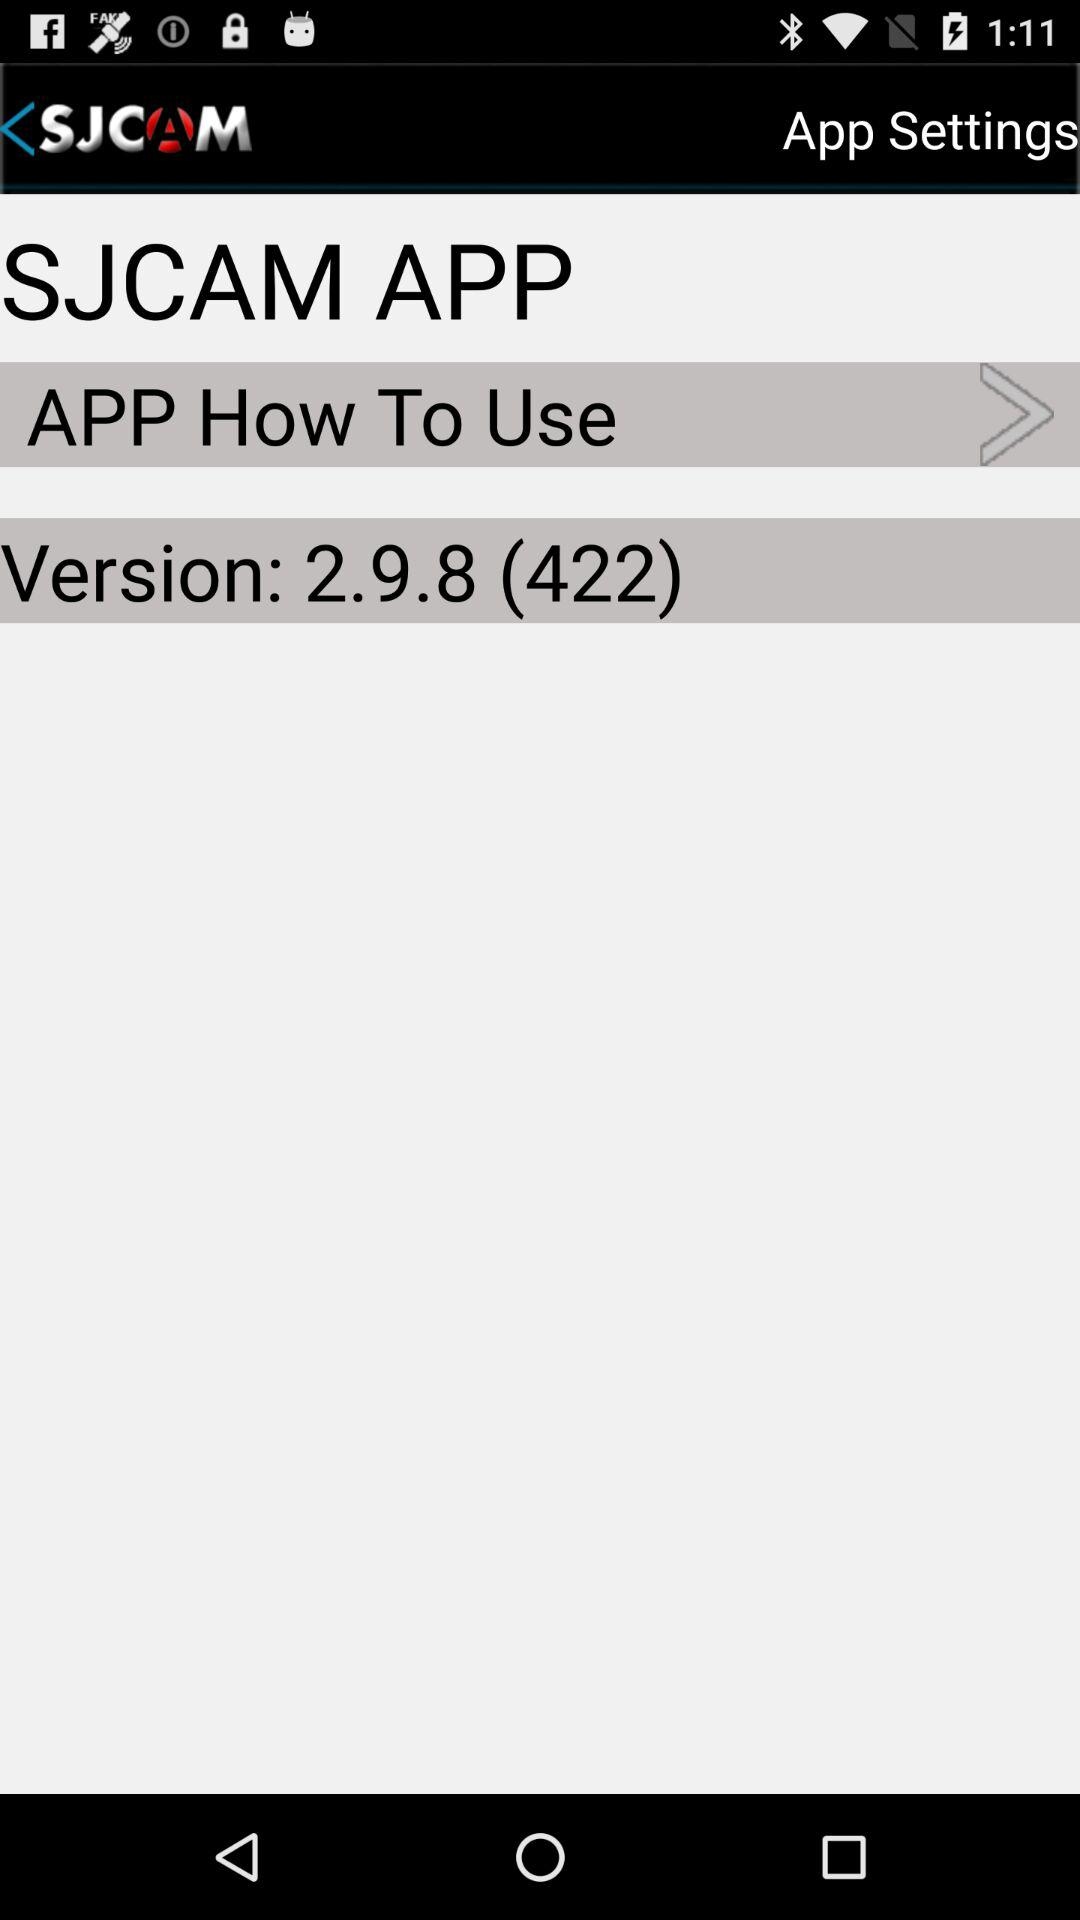What is the version of the app? The version is 2.9.8 (422). 